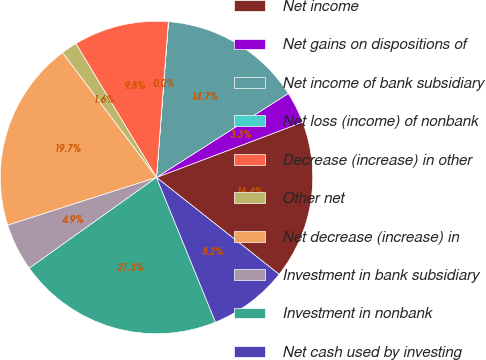Convert chart. <chart><loc_0><loc_0><loc_500><loc_500><pie_chart><fcel>Net income<fcel>Net gains on dispositions of<fcel>Net income of bank subsidiary<fcel>Net loss (income) of nonbank<fcel>Decrease (increase) in other<fcel>Other net<fcel>Net decrease (increase) in<fcel>Investment in bank subsidiary<fcel>Investment in nonbank<fcel>Net cash used by investing<nl><fcel>16.39%<fcel>3.28%<fcel>14.75%<fcel>0.01%<fcel>9.84%<fcel>1.65%<fcel>19.66%<fcel>4.92%<fcel>21.3%<fcel>8.2%<nl></chart> 